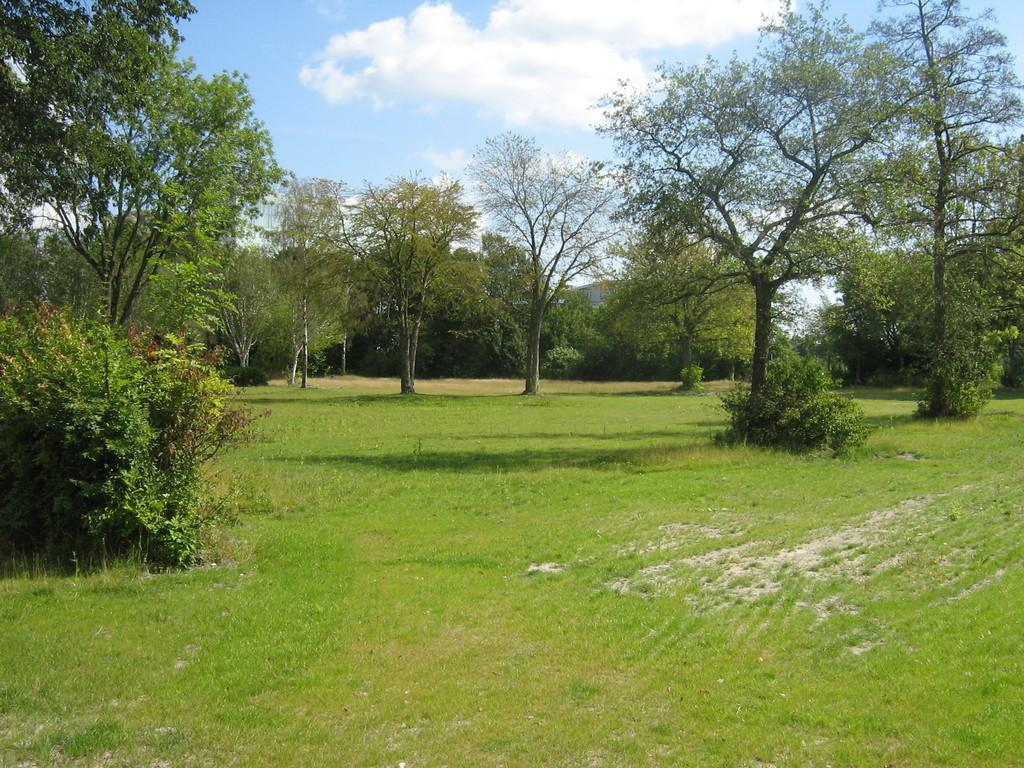What type of vegetation can be seen in the image? There are many trees, plants, and grass in the image. What is visible in the background of the image? The sky is visible in the background of the image. How would you describe the sky in the image? The sky appears to be cloudy in the image. How many oranges are hanging from the trees in the image? There are no oranges visible in the image; it features trees, plants, and grass. Did the earthquake cause any damage to the trees in the image? There is no mention of an earthquake in the image or the provided facts, so we cannot determine if any damage occurred. 